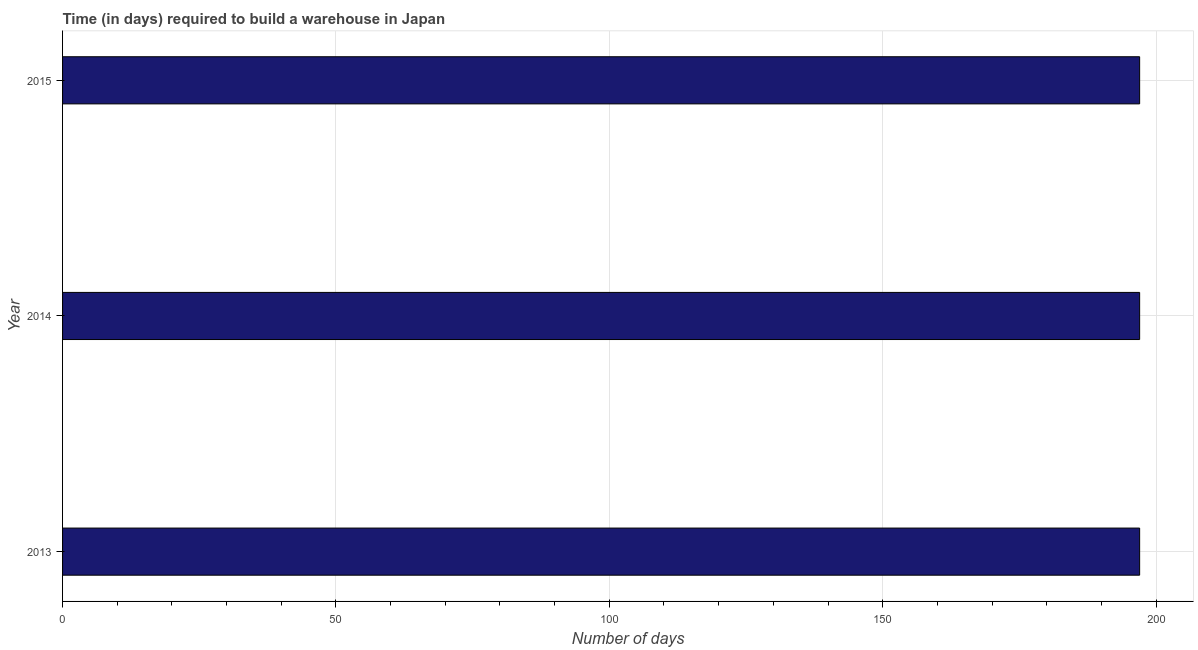Does the graph contain grids?
Give a very brief answer. Yes. What is the title of the graph?
Your answer should be compact. Time (in days) required to build a warehouse in Japan. What is the label or title of the X-axis?
Your answer should be very brief. Number of days. What is the label or title of the Y-axis?
Your answer should be very brief. Year. What is the time required to build a warehouse in 2013?
Ensure brevity in your answer.  197. Across all years, what is the maximum time required to build a warehouse?
Provide a succinct answer. 197. Across all years, what is the minimum time required to build a warehouse?
Offer a terse response. 197. In which year was the time required to build a warehouse minimum?
Make the answer very short. 2013. What is the sum of the time required to build a warehouse?
Your answer should be compact. 591. What is the average time required to build a warehouse per year?
Offer a terse response. 197. What is the median time required to build a warehouse?
Give a very brief answer. 197. In how many years, is the time required to build a warehouse greater than 30 days?
Your answer should be very brief. 3. Do a majority of the years between 2014 and 2013 (inclusive) have time required to build a warehouse greater than 160 days?
Make the answer very short. No. What is the ratio of the time required to build a warehouse in 2013 to that in 2015?
Your answer should be very brief. 1. Is the time required to build a warehouse in 2013 less than that in 2015?
Make the answer very short. No. Is the sum of the time required to build a warehouse in 2014 and 2015 greater than the maximum time required to build a warehouse across all years?
Ensure brevity in your answer.  Yes. What is the difference between the highest and the lowest time required to build a warehouse?
Offer a terse response. 0. Are all the bars in the graph horizontal?
Your answer should be very brief. Yes. How many years are there in the graph?
Your answer should be compact. 3. What is the Number of days of 2013?
Keep it short and to the point. 197. What is the Number of days in 2014?
Provide a succinct answer. 197. What is the Number of days in 2015?
Provide a succinct answer. 197. What is the difference between the Number of days in 2014 and 2015?
Provide a succinct answer. 0. 